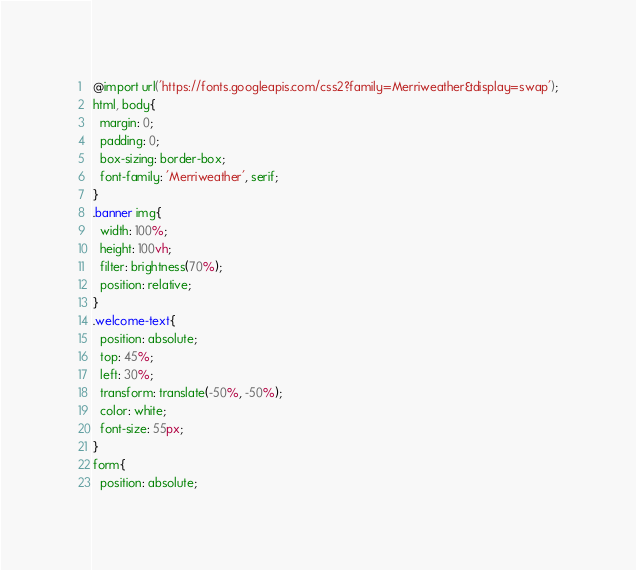<code> <loc_0><loc_0><loc_500><loc_500><_CSS_>@import url('https://fonts.googleapis.com/css2?family=Merriweather&display=swap');
html, body{
  margin: 0;
  padding: 0;
  box-sizing: border-box;
  font-family: 'Merriweather', serif;
}
.banner img{
  width: 100%;
  height: 100vh;
  filter: brightness(70%);
  position: relative;
}
.welcome-text{
  position: absolute;
  top: 45%;
  left: 30%;
  transform: translate(-50%, -50%);
  color: white;
  font-size: 55px;
}
form{
  position: absolute;</code> 